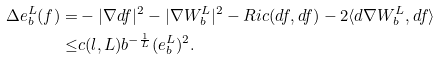Convert formula to latex. <formula><loc_0><loc_0><loc_500><loc_500>\Delta e _ { b } ^ { L } ( f ) = & - | \nabla d f | ^ { 2 } - | \nabla W _ { b } ^ { L } | ^ { 2 } - R i c ( d f , d f ) - 2 \langle d \nabla W _ { b } ^ { L } , d f \rangle \\ \leq & c ( l , L ) b ^ { - \frac { 1 } { L } } ( e _ { b } ^ { L } ) ^ { 2 } .</formula> 